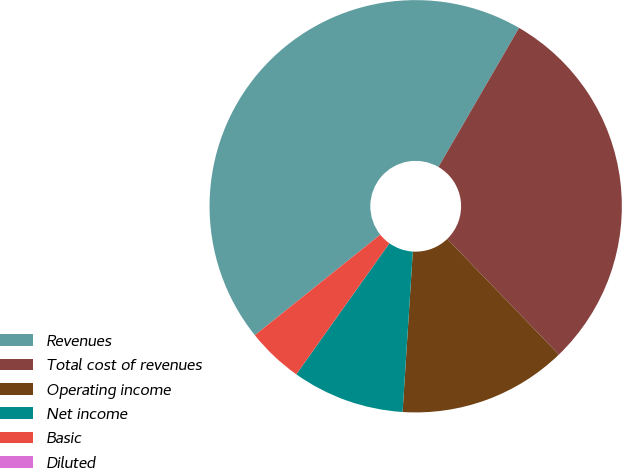Convert chart. <chart><loc_0><loc_0><loc_500><loc_500><pie_chart><fcel>Revenues<fcel>Total cost of revenues<fcel>Operating income<fcel>Net income<fcel>Basic<fcel>Diluted<nl><fcel>44.11%<fcel>29.42%<fcel>13.23%<fcel>8.82%<fcel>4.41%<fcel>0.0%<nl></chart> 